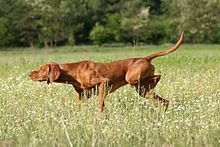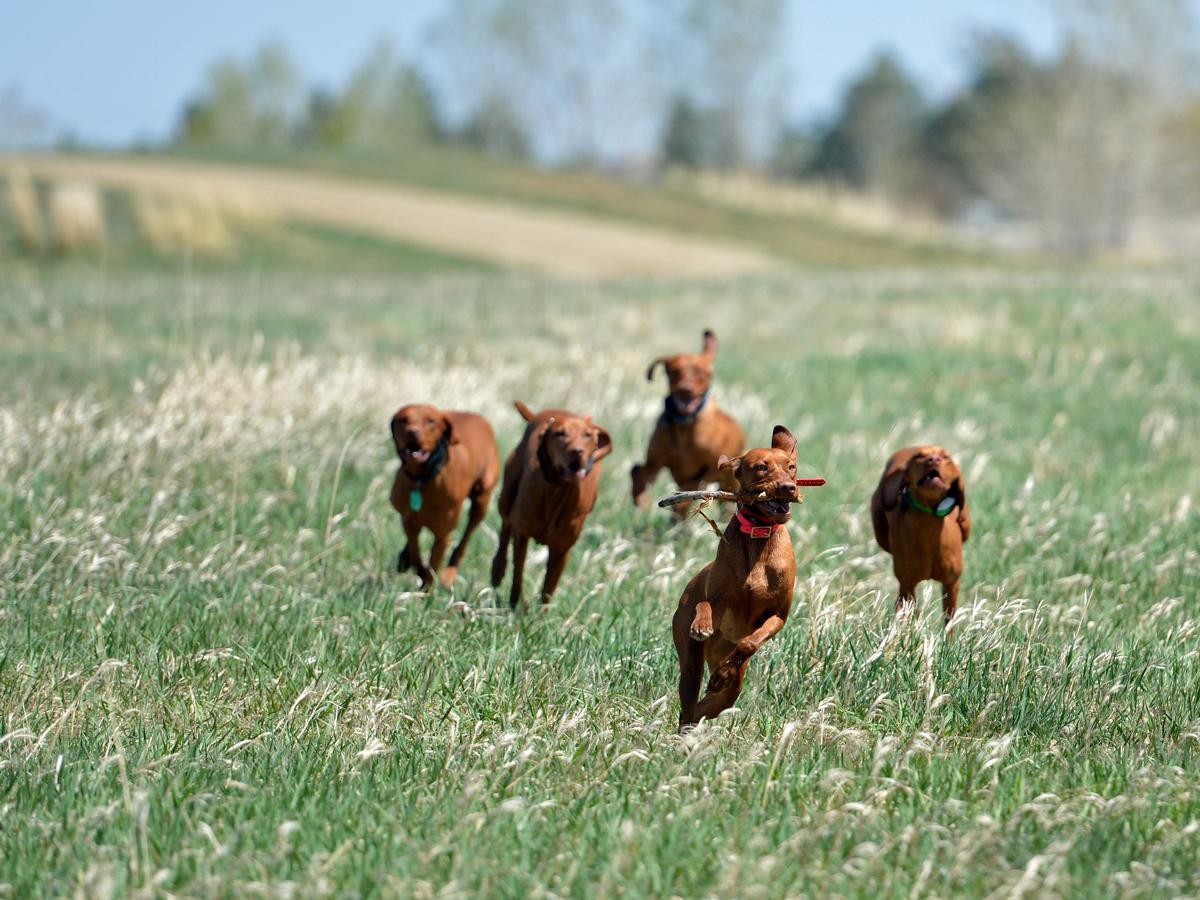The first image is the image on the left, the second image is the image on the right. Assess this claim about the two images: "One of the images features a pair of dogs together.". Correct or not? Answer yes or no. No. The first image is the image on the left, the second image is the image on the right. Evaluate the accuracy of this statement regarding the images: "In one image there is a single dog and in the other image there are 2 dogs.". Is it true? Answer yes or no. No. 